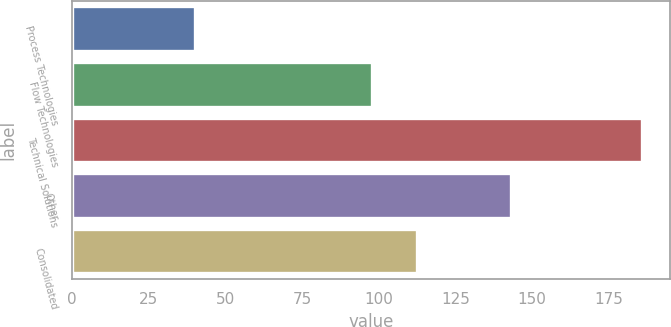Convert chart to OTSL. <chart><loc_0><loc_0><loc_500><loc_500><bar_chart><fcel>Process Technologies<fcel>Flow Technologies<fcel>Technical Solutions<fcel>Other<fcel>Consolidated<nl><fcel>40.2<fcel>97.9<fcel>185.8<fcel>143.3<fcel>112.46<nl></chart> 